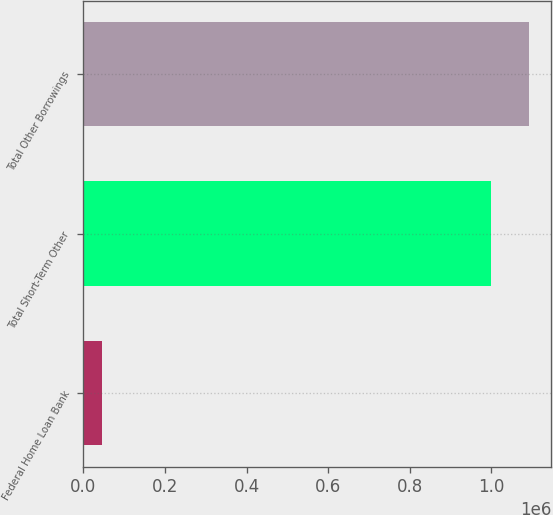<chart> <loc_0><loc_0><loc_500><loc_500><bar_chart><fcel>Federal Home Loan Bank<fcel>Total Short-Term Other<fcel>Total Other Borrowings<nl><fcel>45000<fcel>998500<fcel>1.092e+06<nl></chart> 